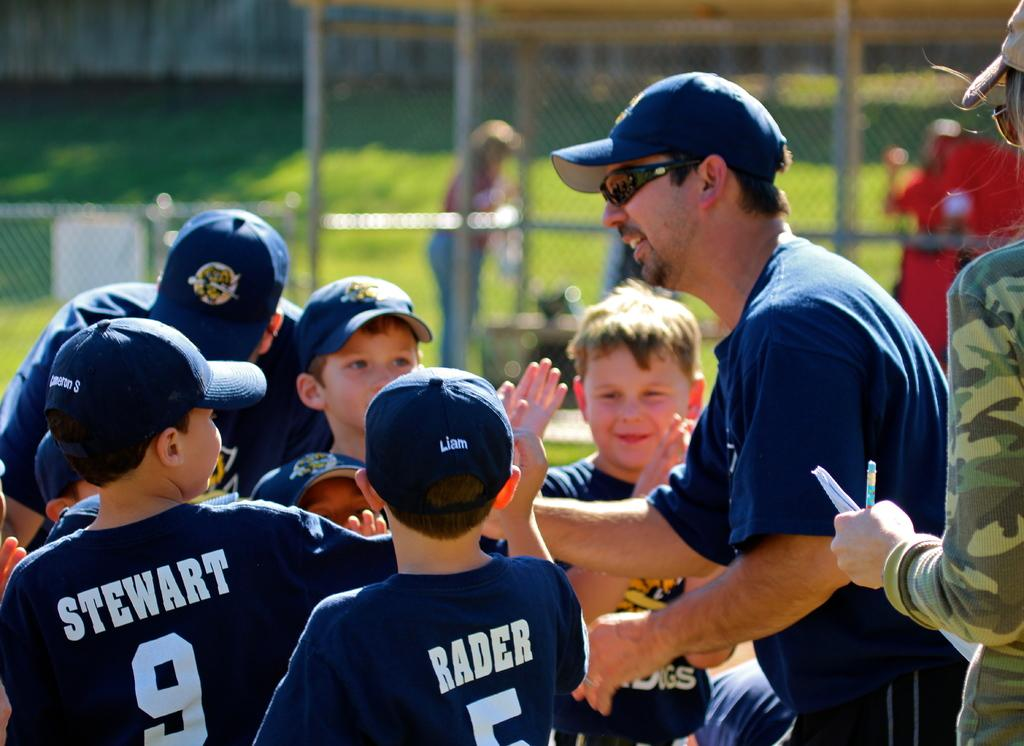<image>
Present a compact description of the photo's key features. Stewart, Rader and some other Little League teammates high five their coach. 